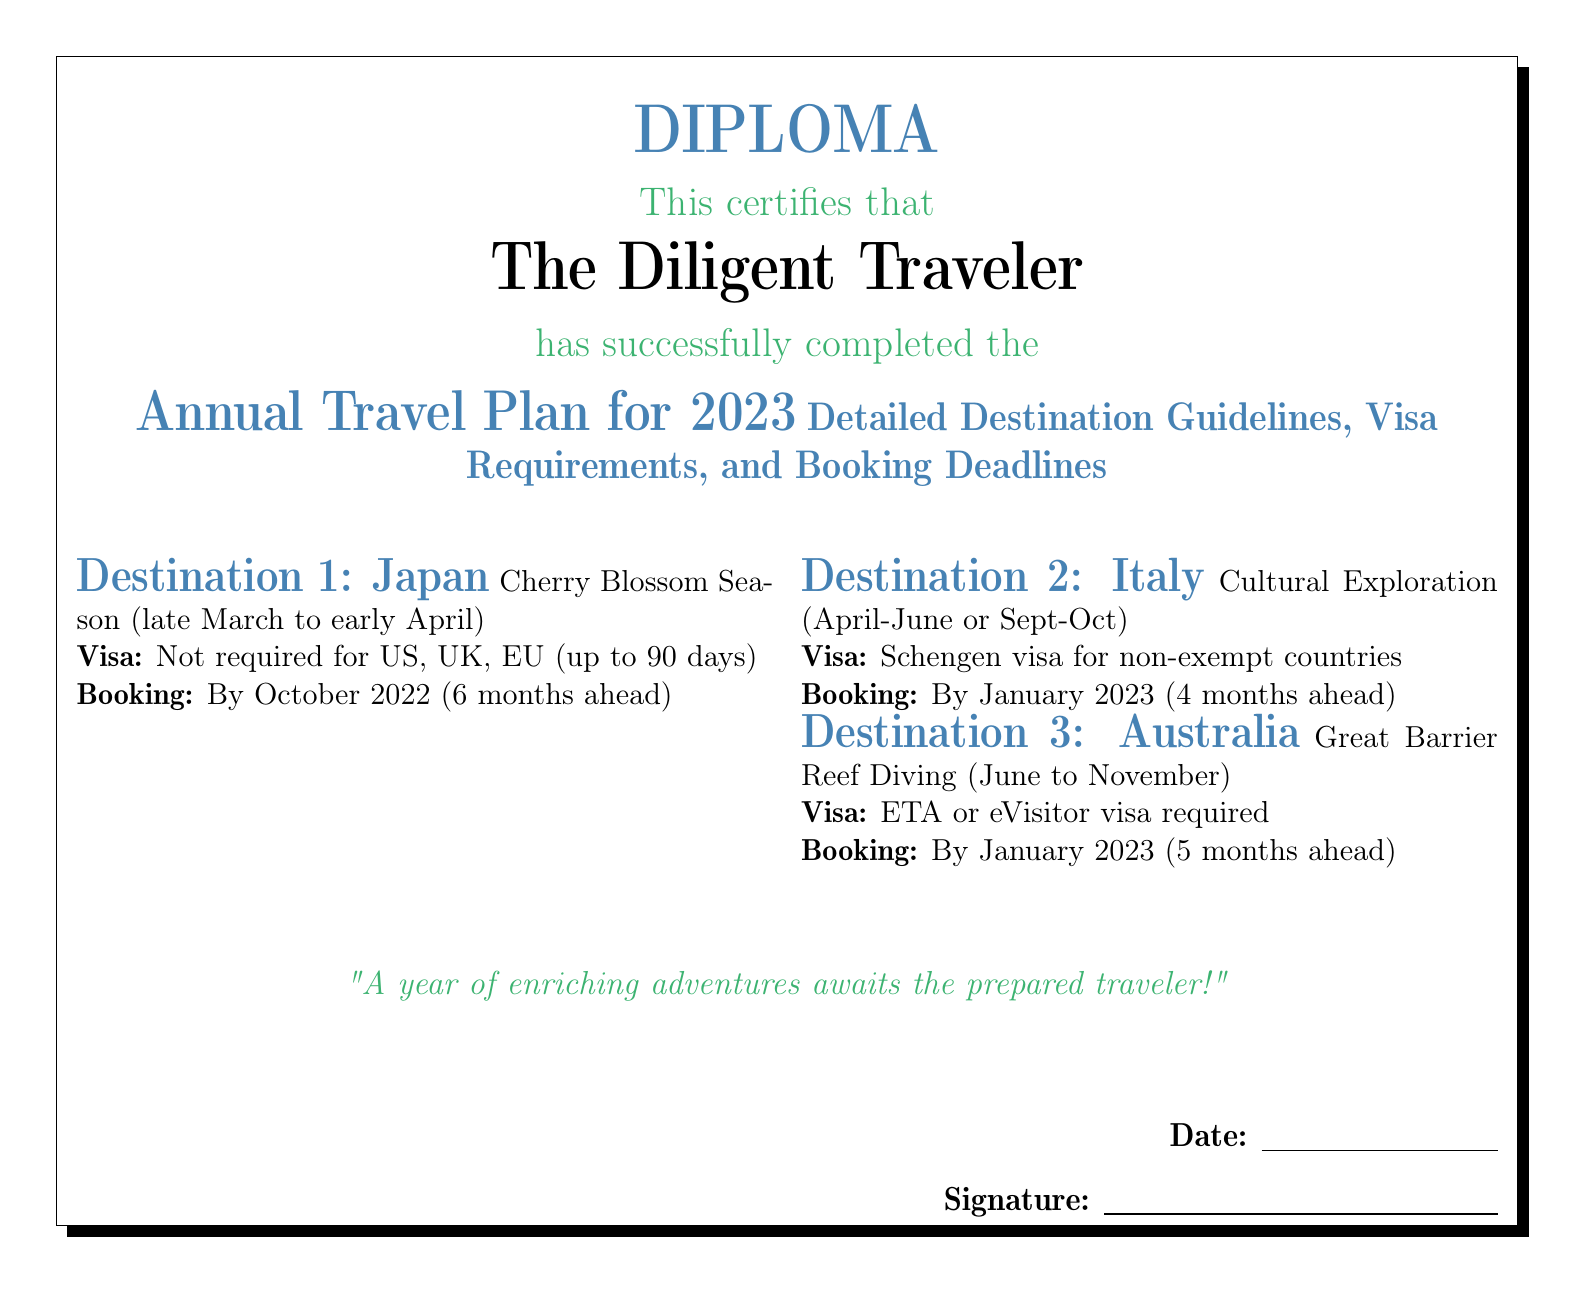What is the purpose of the document? The document certifies the completion of an annual travel plan for 2023, including destination guidelines, visa requirements, and booking deadlines.
Answer: Annual Travel Plan for 2023 What is the visa requirement for Japan? The document states that no visa is required for citizens from specific countries for a stay up to 90 days.
Answer: Not required for US, UK, EU What is the booking deadline for Italy? The document specifies the timeframe for making reservations to ensure a successful trip to Italy.
Answer: By January 2023 How many destinations are listed in the document? The number of destinations detailed in the document indicates its scope for travel planning in 2023.
Answer: Three What season is recommended for visiting Australia? The document outlines the best time to visit Australia, specifically for an activity.
Answer: June to November What type of visa is needed for Australia? The document provides clear information on the visa type required for traveling to Australia.
Answer: ETA or eVisitor visa What is the suggested period for cultural exploration in Italy? The specific time frames for visiting Italy are provided in the document to optimize the travel experience.
Answer: April-June or Sept-Oct Who is certified in this document? The individual named in the document indicates the person who completed the travel plan.
Answer: The Diligent Traveler What quote is included in the document? The quote included in the document serves to inspire the reader about the traveling experience.
Answer: A year of enriching adventures awaits the prepared traveler! 